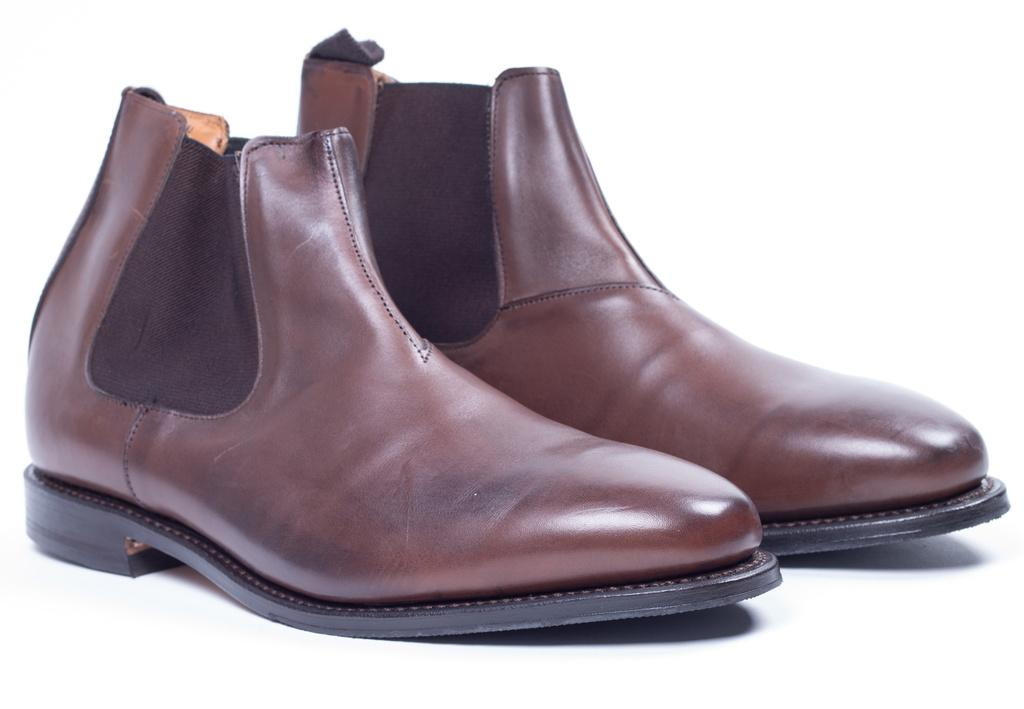What type of footwear is visible in the image? There are two brown color shoes in the image. Where are the shoes placed in the image? The shoes are on a surface. What color is the background of the image? The background of the image is white in color. What type of corn is being grown in the jail during the vacation in the image? There is no corn, jail, or vacation mentioned or depicted in the image. 